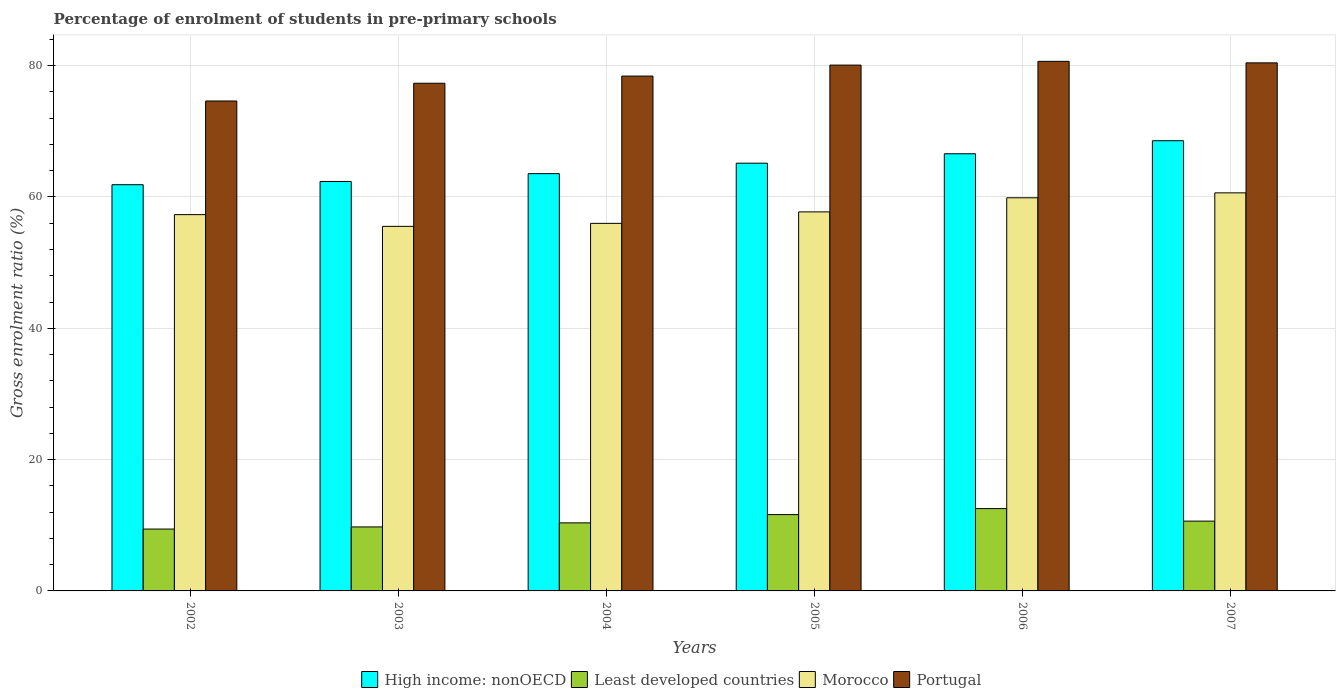How many different coloured bars are there?
Your response must be concise. 4. Are the number of bars on each tick of the X-axis equal?
Your answer should be very brief. Yes. How many bars are there on the 6th tick from the left?
Your answer should be very brief. 4. How many bars are there on the 3rd tick from the right?
Ensure brevity in your answer.  4. What is the percentage of students enrolled in pre-primary schools in Least developed countries in 2005?
Your answer should be compact. 11.62. Across all years, what is the maximum percentage of students enrolled in pre-primary schools in Portugal?
Ensure brevity in your answer.  80.65. Across all years, what is the minimum percentage of students enrolled in pre-primary schools in Least developed countries?
Ensure brevity in your answer.  9.42. In which year was the percentage of students enrolled in pre-primary schools in Morocco maximum?
Provide a succinct answer. 2007. What is the total percentage of students enrolled in pre-primary schools in Portugal in the graph?
Your answer should be very brief. 471.51. What is the difference between the percentage of students enrolled in pre-primary schools in High income: nonOECD in 2003 and that in 2006?
Your response must be concise. -4.22. What is the difference between the percentage of students enrolled in pre-primary schools in Portugal in 2006 and the percentage of students enrolled in pre-primary schools in Morocco in 2002?
Provide a succinct answer. 23.34. What is the average percentage of students enrolled in pre-primary schools in Morocco per year?
Give a very brief answer. 57.84. In the year 2003, what is the difference between the percentage of students enrolled in pre-primary schools in High income: nonOECD and percentage of students enrolled in pre-primary schools in Morocco?
Give a very brief answer. 6.84. What is the ratio of the percentage of students enrolled in pre-primary schools in Least developed countries in 2002 to that in 2003?
Your response must be concise. 0.97. Is the difference between the percentage of students enrolled in pre-primary schools in High income: nonOECD in 2002 and 2004 greater than the difference between the percentage of students enrolled in pre-primary schools in Morocco in 2002 and 2004?
Provide a short and direct response. No. What is the difference between the highest and the second highest percentage of students enrolled in pre-primary schools in High income: nonOECD?
Your answer should be compact. 1.98. What is the difference between the highest and the lowest percentage of students enrolled in pre-primary schools in High income: nonOECD?
Your answer should be compact. 6.7. Is the sum of the percentage of students enrolled in pre-primary schools in High income: nonOECD in 2003 and 2005 greater than the maximum percentage of students enrolled in pre-primary schools in Least developed countries across all years?
Your response must be concise. Yes. What does the 3rd bar from the left in 2006 represents?
Ensure brevity in your answer.  Morocco. What does the 2nd bar from the right in 2006 represents?
Provide a short and direct response. Morocco. Is it the case that in every year, the sum of the percentage of students enrolled in pre-primary schools in Portugal and percentage of students enrolled in pre-primary schools in Least developed countries is greater than the percentage of students enrolled in pre-primary schools in High income: nonOECD?
Make the answer very short. Yes. Are all the bars in the graph horizontal?
Offer a very short reply. No. What is the difference between two consecutive major ticks on the Y-axis?
Your answer should be compact. 20. Does the graph contain any zero values?
Provide a short and direct response. No. How are the legend labels stacked?
Your answer should be very brief. Horizontal. What is the title of the graph?
Your answer should be compact. Percentage of enrolment of students in pre-primary schools. What is the label or title of the X-axis?
Your answer should be compact. Years. What is the Gross enrolment ratio (%) in High income: nonOECD in 2002?
Your answer should be compact. 61.87. What is the Gross enrolment ratio (%) in Least developed countries in 2002?
Your response must be concise. 9.42. What is the Gross enrolment ratio (%) in Morocco in 2002?
Your answer should be very brief. 57.31. What is the Gross enrolment ratio (%) in Portugal in 2002?
Your response must be concise. 74.62. What is the Gross enrolment ratio (%) in High income: nonOECD in 2003?
Your answer should be compact. 62.36. What is the Gross enrolment ratio (%) in Least developed countries in 2003?
Provide a succinct answer. 9.75. What is the Gross enrolment ratio (%) in Morocco in 2003?
Offer a very short reply. 55.52. What is the Gross enrolment ratio (%) in Portugal in 2003?
Your answer should be compact. 77.32. What is the Gross enrolment ratio (%) in High income: nonOECD in 2004?
Give a very brief answer. 63.55. What is the Gross enrolment ratio (%) of Least developed countries in 2004?
Make the answer very short. 10.37. What is the Gross enrolment ratio (%) of Morocco in 2004?
Your answer should be compact. 55.98. What is the Gross enrolment ratio (%) of Portugal in 2004?
Your response must be concise. 78.41. What is the Gross enrolment ratio (%) in High income: nonOECD in 2005?
Offer a very short reply. 65.14. What is the Gross enrolment ratio (%) in Least developed countries in 2005?
Offer a very short reply. 11.62. What is the Gross enrolment ratio (%) of Morocco in 2005?
Your response must be concise. 57.73. What is the Gross enrolment ratio (%) in Portugal in 2005?
Make the answer very short. 80.08. What is the Gross enrolment ratio (%) in High income: nonOECD in 2006?
Your response must be concise. 66.58. What is the Gross enrolment ratio (%) of Least developed countries in 2006?
Your answer should be very brief. 12.54. What is the Gross enrolment ratio (%) of Morocco in 2006?
Keep it short and to the point. 59.88. What is the Gross enrolment ratio (%) in Portugal in 2006?
Keep it short and to the point. 80.65. What is the Gross enrolment ratio (%) in High income: nonOECD in 2007?
Give a very brief answer. 68.56. What is the Gross enrolment ratio (%) of Least developed countries in 2007?
Offer a very short reply. 10.63. What is the Gross enrolment ratio (%) in Morocco in 2007?
Keep it short and to the point. 60.63. What is the Gross enrolment ratio (%) in Portugal in 2007?
Offer a terse response. 80.43. Across all years, what is the maximum Gross enrolment ratio (%) of High income: nonOECD?
Make the answer very short. 68.56. Across all years, what is the maximum Gross enrolment ratio (%) in Least developed countries?
Your answer should be very brief. 12.54. Across all years, what is the maximum Gross enrolment ratio (%) of Morocco?
Your answer should be very brief. 60.63. Across all years, what is the maximum Gross enrolment ratio (%) of Portugal?
Keep it short and to the point. 80.65. Across all years, what is the minimum Gross enrolment ratio (%) in High income: nonOECD?
Provide a short and direct response. 61.87. Across all years, what is the minimum Gross enrolment ratio (%) of Least developed countries?
Your answer should be compact. 9.42. Across all years, what is the minimum Gross enrolment ratio (%) of Morocco?
Your answer should be very brief. 55.52. Across all years, what is the minimum Gross enrolment ratio (%) in Portugal?
Keep it short and to the point. 74.62. What is the total Gross enrolment ratio (%) of High income: nonOECD in the graph?
Your response must be concise. 388.07. What is the total Gross enrolment ratio (%) in Least developed countries in the graph?
Your response must be concise. 64.33. What is the total Gross enrolment ratio (%) of Morocco in the graph?
Provide a succinct answer. 347.04. What is the total Gross enrolment ratio (%) in Portugal in the graph?
Ensure brevity in your answer.  471.51. What is the difference between the Gross enrolment ratio (%) of High income: nonOECD in 2002 and that in 2003?
Ensure brevity in your answer.  -0.49. What is the difference between the Gross enrolment ratio (%) in Least developed countries in 2002 and that in 2003?
Provide a short and direct response. -0.32. What is the difference between the Gross enrolment ratio (%) in Morocco in 2002 and that in 2003?
Offer a terse response. 1.79. What is the difference between the Gross enrolment ratio (%) in Portugal in 2002 and that in 2003?
Offer a very short reply. -2.7. What is the difference between the Gross enrolment ratio (%) of High income: nonOECD in 2002 and that in 2004?
Provide a short and direct response. -1.68. What is the difference between the Gross enrolment ratio (%) in Least developed countries in 2002 and that in 2004?
Make the answer very short. -0.94. What is the difference between the Gross enrolment ratio (%) of Morocco in 2002 and that in 2004?
Offer a terse response. 1.33. What is the difference between the Gross enrolment ratio (%) in Portugal in 2002 and that in 2004?
Make the answer very short. -3.79. What is the difference between the Gross enrolment ratio (%) in High income: nonOECD in 2002 and that in 2005?
Your answer should be very brief. -3.28. What is the difference between the Gross enrolment ratio (%) in Least developed countries in 2002 and that in 2005?
Offer a terse response. -2.2. What is the difference between the Gross enrolment ratio (%) in Morocco in 2002 and that in 2005?
Ensure brevity in your answer.  -0.42. What is the difference between the Gross enrolment ratio (%) of Portugal in 2002 and that in 2005?
Give a very brief answer. -5.47. What is the difference between the Gross enrolment ratio (%) in High income: nonOECD in 2002 and that in 2006?
Ensure brevity in your answer.  -4.72. What is the difference between the Gross enrolment ratio (%) of Least developed countries in 2002 and that in 2006?
Ensure brevity in your answer.  -3.11. What is the difference between the Gross enrolment ratio (%) in Morocco in 2002 and that in 2006?
Keep it short and to the point. -2.57. What is the difference between the Gross enrolment ratio (%) in Portugal in 2002 and that in 2006?
Give a very brief answer. -6.04. What is the difference between the Gross enrolment ratio (%) of High income: nonOECD in 2002 and that in 2007?
Your response must be concise. -6.7. What is the difference between the Gross enrolment ratio (%) of Least developed countries in 2002 and that in 2007?
Your answer should be very brief. -1.21. What is the difference between the Gross enrolment ratio (%) in Morocco in 2002 and that in 2007?
Ensure brevity in your answer.  -3.32. What is the difference between the Gross enrolment ratio (%) in Portugal in 2002 and that in 2007?
Keep it short and to the point. -5.81. What is the difference between the Gross enrolment ratio (%) of High income: nonOECD in 2003 and that in 2004?
Your answer should be very brief. -1.19. What is the difference between the Gross enrolment ratio (%) of Least developed countries in 2003 and that in 2004?
Your response must be concise. -0.62. What is the difference between the Gross enrolment ratio (%) in Morocco in 2003 and that in 2004?
Your answer should be very brief. -0.46. What is the difference between the Gross enrolment ratio (%) of Portugal in 2003 and that in 2004?
Your response must be concise. -1.09. What is the difference between the Gross enrolment ratio (%) in High income: nonOECD in 2003 and that in 2005?
Your answer should be compact. -2.78. What is the difference between the Gross enrolment ratio (%) in Least developed countries in 2003 and that in 2005?
Keep it short and to the point. -1.88. What is the difference between the Gross enrolment ratio (%) of Morocco in 2003 and that in 2005?
Offer a terse response. -2.2. What is the difference between the Gross enrolment ratio (%) in Portugal in 2003 and that in 2005?
Your response must be concise. -2.76. What is the difference between the Gross enrolment ratio (%) in High income: nonOECD in 2003 and that in 2006?
Keep it short and to the point. -4.22. What is the difference between the Gross enrolment ratio (%) of Least developed countries in 2003 and that in 2006?
Offer a very short reply. -2.79. What is the difference between the Gross enrolment ratio (%) of Morocco in 2003 and that in 2006?
Make the answer very short. -4.35. What is the difference between the Gross enrolment ratio (%) of Portugal in 2003 and that in 2006?
Provide a short and direct response. -3.33. What is the difference between the Gross enrolment ratio (%) of High income: nonOECD in 2003 and that in 2007?
Ensure brevity in your answer.  -6.2. What is the difference between the Gross enrolment ratio (%) of Least developed countries in 2003 and that in 2007?
Your response must be concise. -0.88. What is the difference between the Gross enrolment ratio (%) in Morocco in 2003 and that in 2007?
Provide a succinct answer. -5.1. What is the difference between the Gross enrolment ratio (%) in Portugal in 2003 and that in 2007?
Ensure brevity in your answer.  -3.11. What is the difference between the Gross enrolment ratio (%) of High income: nonOECD in 2004 and that in 2005?
Ensure brevity in your answer.  -1.59. What is the difference between the Gross enrolment ratio (%) in Least developed countries in 2004 and that in 2005?
Provide a short and direct response. -1.26. What is the difference between the Gross enrolment ratio (%) of Morocco in 2004 and that in 2005?
Your response must be concise. -1.75. What is the difference between the Gross enrolment ratio (%) of Portugal in 2004 and that in 2005?
Offer a terse response. -1.67. What is the difference between the Gross enrolment ratio (%) in High income: nonOECD in 2004 and that in 2006?
Keep it short and to the point. -3.03. What is the difference between the Gross enrolment ratio (%) of Least developed countries in 2004 and that in 2006?
Your answer should be very brief. -2.17. What is the difference between the Gross enrolment ratio (%) in Morocco in 2004 and that in 2006?
Make the answer very short. -3.9. What is the difference between the Gross enrolment ratio (%) of Portugal in 2004 and that in 2006?
Provide a short and direct response. -2.24. What is the difference between the Gross enrolment ratio (%) of High income: nonOECD in 2004 and that in 2007?
Keep it short and to the point. -5.01. What is the difference between the Gross enrolment ratio (%) of Least developed countries in 2004 and that in 2007?
Keep it short and to the point. -0.27. What is the difference between the Gross enrolment ratio (%) of Morocco in 2004 and that in 2007?
Your answer should be compact. -4.65. What is the difference between the Gross enrolment ratio (%) in Portugal in 2004 and that in 2007?
Keep it short and to the point. -2.01. What is the difference between the Gross enrolment ratio (%) of High income: nonOECD in 2005 and that in 2006?
Your answer should be compact. -1.44. What is the difference between the Gross enrolment ratio (%) in Least developed countries in 2005 and that in 2006?
Provide a short and direct response. -0.91. What is the difference between the Gross enrolment ratio (%) in Morocco in 2005 and that in 2006?
Offer a terse response. -2.15. What is the difference between the Gross enrolment ratio (%) in Portugal in 2005 and that in 2006?
Provide a succinct answer. -0.57. What is the difference between the Gross enrolment ratio (%) in High income: nonOECD in 2005 and that in 2007?
Offer a terse response. -3.42. What is the difference between the Gross enrolment ratio (%) of Morocco in 2005 and that in 2007?
Provide a succinct answer. -2.9. What is the difference between the Gross enrolment ratio (%) in Portugal in 2005 and that in 2007?
Give a very brief answer. -0.34. What is the difference between the Gross enrolment ratio (%) of High income: nonOECD in 2006 and that in 2007?
Give a very brief answer. -1.98. What is the difference between the Gross enrolment ratio (%) in Least developed countries in 2006 and that in 2007?
Your answer should be compact. 1.91. What is the difference between the Gross enrolment ratio (%) of Morocco in 2006 and that in 2007?
Your answer should be very brief. -0.75. What is the difference between the Gross enrolment ratio (%) in Portugal in 2006 and that in 2007?
Make the answer very short. 0.23. What is the difference between the Gross enrolment ratio (%) in High income: nonOECD in 2002 and the Gross enrolment ratio (%) in Least developed countries in 2003?
Your response must be concise. 52.12. What is the difference between the Gross enrolment ratio (%) of High income: nonOECD in 2002 and the Gross enrolment ratio (%) of Morocco in 2003?
Your answer should be compact. 6.34. What is the difference between the Gross enrolment ratio (%) of High income: nonOECD in 2002 and the Gross enrolment ratio (%) of Portugal in 2003?
Your answer should be compact. -15.45. What is the difference between the Gross enrolment ratio (%) in Least developed countries in 2002 and the Gross enrolment ratio (%) in Morocco in 2003?
Offer a very short reply. -46.1. What is the difference between the Gross enrolment ratio (%) of Least developed countries in 2002 and the Gross enrolment ratio (%) of Portugal in 2003?
Make the answer very short. -67.9. What is the difference between the Gross enrolment ratio (%) in Morocco in 2002 and the Gross enrolment ratio (%) in Portugal in 2003?
Offer a very short reply. -20.01. What is the difference between the Gross enrolment ratio (%) of High income: nonOECD in 2002 and the Gross enrolment ratio (%) of Least developed countries in 2004?
Ensure brevity in your answer.  51.5. What is the difference between the Gross enrolment ratio (%) in High income: nonOECD in 2002 and the Gross enrolment ratio (%) in Morocco in 2004?
Make the answer very short. 5.89. What is the difference between the Gross enrolment ratio (%) in High income: nonOECD in 2002 and the Gross enrolment ratio (%) in Portugal in 2004?
Provide a succinct answer. -16.55. What is the difference between the Gross enrolment ratio (%) in Least developed countries in 2002 and the Gross enrolment ratio (%) in Morocco in 2004?
Your answer should be compact. -46.56. What is the difference between the Gross enrolment ratio (%) in Least developed countries in 2002 and the Gross enrolment ratio (%) in Portugal in 2004?
Your answer should be very brief. -68.99. What is the difference between the Gross enrolment ratio (%) of Morocco in 2002 and the Gross enrolment ratio (%) of Portugal in 2004?
Ensure brevity in your answer.  -21.1. What is the difference between the Gross enrolment ratio (%) in High income: nonOECD in 2002 and the Gross enrolment ratio (%) in Least developed countries in 2005?
Make the answer very short. 50.24. What is the difference between the Gross enrolment ratio (%) in High income: nonOECD in 2002 and the Gross enrolment ratio (%) in Morocco in 2005?
Offer a very short reply. 4.14. What is the difference between the Gross enrolment ratio (%) of High income: nonOECD in 2002 and the Gross enrolment ratio (%) of Portugal in 2005?
Provide a short and direct response. -18.22. What is the difference between the Gross enrolment ratio (%) of Least developed countries in 2002 and the Gross enrolment ratio (%) of Morocco in 2005?
Your answer should be compact. -48.3. What is the difference between the Gross enrolment ratio (%) in Least developed countries in 2002 and the Gross enrolment ratio (%) in Portugal in 2005?
Provide a succinct answer. -70.66. What is the difference between the Gross enrolment ratio (%) in Morocco in 2002 and the Gross enrolment ratio (%) in Portugal in 2005?
Provide a short and direct response. -22.77. What is the difference between the Gross enrolment ratio (%) in High income: nonOECD in 2002 and the Gross enrolment ratio (%) in Least developed countries in 2006?
Keep it short and to the point. 49.33. What is the difference between the Gross enrolment ratio (%) of High income: nonOECD in 2002 and the Gross enrolment ratio (%) of Morocco in 2006?
Offer a very short reply. 1.99. What is the difference between the Gross enrolment ratio (%) in High income: nonOECD in 2002 and the Gross enrolment ratio (%) in Portugal in 2006?
Offer a terse response. -18.79. What is the difference between the Gross enrolment ratio (%) of Least developed countries in 2002 and the Gross enrolment ratio (%) of Morocco in 2006?
Your answer should be very brief. -50.45. What is the difference between the Gross enrolment ratio (%) in Least developed countries in 2002 and the Gross enrolment ratio (%) in Portugal in 2006?
Offer a terse response. -71.23. What is the difference between the Gross enrolment ratio (%) in Morocco in 2002 and the Gross enrolment ratio (%) in Portugal in 2006?
Give a very brief answer. -23.34. What is the difference between the Gross enrolment ratio (%) of High income: nonOECD in 2002 and the Gross enrolment ratio (%) of Least developed countries in 2007?
Offer a terse response. 51.24. What is the difference between the Gross enrolment ratio (%) of High income: nonOECD in 2002 and the Gross enrolment ratio (%) of Morocco in 2007?
Provide a short and direct response. 1.24. What is the difference between the Gross enrolment ratio (%) in High income: nonOECD in 2002 and the Gross enrolment ratio (%) in Portugal in 2007?
Offer a terse response. -18.56. What is the difference between the Gross enrolment ratio (%) in Least developed countries in 2002 and the Gross enrolment ratio (%) in Morocco in 2007?
Make the answer very short. -51.2. What is the difference between the Gross enrolment ratio (%) in Least developed countries in 2002 and the Gross enrolment ratio (%) in Portugal in 2007?
Offer a terse response. -71. What is the difference between the Gross enrolment ratio (%) of Morocco in 2002 and the Gross enrolment ratio (%) of Portugal in 2007?
Ensure brevity in your answer.  -23.12. What is the difference between the Gross enrolment ratio (%) of High income: nonOECD in 2003 and the Gross enrolment ratio (%) of Least developed countries in 2004?
Make the answer very short. 51.99. What is the difference between the Gross enrolment ratio (%) in High income: nonOECD in 2003 and the Gross enrolment ratio (%) in Morocco in 2004?
Offer a very short reply. 6.38. What is the difference between the Gross enrolment ratio (%) in High income: nonOECD in 2003 and the Gross enrolment ratio (%) in Portugal in 2004?
Make the answer very short. -16.05. What is the difference between the Gross enrolment ratio (%) in Least developed countries in 2003 and the Gross enrolment ratio (%) in Morocco in 2004?
Your response must be concise. -46.23. What is the difference between the Gross enrolment ratio (%) in Least developed countries in 2003 and the Gross enrolment ratio (%) in Portugal in 2004?
Give a very brief answer. -68.66. What is the difference between the Gross enrolment ratio (%) of Morocco in 2003 and the Gross enrolment ratio (%) of Portugal in 2004?
Ensure brevity in your answer.  -22.89. What is the difference between the Gross enrolment ratio (%) of High income: nonOECD in 2003 and the Gross enrolment ratio (%) of Least developed countries in 2005?
Provide a succinct answer. 50.74. What is the difference between the Gross enrolment ratio (%) of High income: nonOECD in 2003 and the Gross enrolment ratio (%) of Morocco in 2005?
Make the answer very short. 4.63. What is the difference between the Gross enrolment ratio (%) of High income: nonOECD in 2003 and the Gross enrolment ratio (%) of Portugal in 2005?
Offer a very short reply. -17.72. What is the difference between the Gross enrolment ratio (%) in Least developed countries in 2003 and the Gross enrolment ratio (%) in Morocco in 2005?
Give a very brief answer. -47.98. What is the difference between the Gross enrolment ratio (%) in Least developed countries in 2003 and the Gross enrolment ratio (%) in Portugal in 2005?
Give a very brief answer. -70.34. What is the difference between the Gross enrolment ratio (%) in Morocco in 2003 and the Gross enrolment ratio (%) in Portugal in 2005?
Your answer should be compact. -24.56. What is the difference between the Gross enrolment ratio (%) of High income: nonOECD in 2003 and the Gross enrolment ratio (%) of Least developed countries in 2006?
Your answer should be compact. 49.82. What is the difference between the Gross enrolment ratio (%) in High income: nonOECD in 2003 and the Gross enrolment ratio (%) in Morocco in 2006?
Keep it short and to the point. 2.48. What is the difference between the Gross enrolment ratio (%) in High income: nonOECD in 2003 and the Gross enrolment ratio (%) in Portugal in 2006?
Ensure brevity in your answer.  -18.29. What is the difference between the Gross enrolment ratio (%) of Least developed countries in 2003 and the Gross enrolment ratio (%) of Morocco in 2006?
Make the answer very short. -50.13. What is the difference between the Gross enrolment ratio (%) of Least developed countries in 2003 and the Gross enrolment ratio (%) of Portugal in 2006?
Provide a short and direct response. -70.91. What is the difference between the Gross enrolment ratio (%) of Morocco in 2003 and the Gross enrolment ratio (%) of Portugal in 2006?
Your answer should be compact. -25.13. What is the difference between the Gross enrolment ratio (%) of High income: nonOECD in 2003 and the Gross enrolment ratio (%) of Least developed countries in 2007?
Offer a terse response. 51.73. What is the difference between the Gross enrolment ratio (%) of High income: nonOECD in 2003 and the Gross enrolment ratio (%) of Morocco in 2007?
Offer a very short reply. 1.73. What is the difference between the Gross enrolment ratio (%) of High income: nonOECD in 2003 and the Gross enrolment ratio (%) of Portugal in 2007?
Provide a short and direct response. -18.07. What is the difference between the Gross enrolment ratio (%) in Least developed countries in 2003 and the Gross enrolment ratio (%) in Morocco in 2007?
Your response must be concise. -50.88. What is the difference between the Gross enrolment ratio (%) in Least developed countries in 2003 and the Gross enrolment ratio (%) in Portugal in 2007?
Your answer should be very brief. -70.68. What is the difference between the Gross enrolment ratio (%) in Morocco in 2003 and the Gross enrolment ratio (%) in Portugal in 2007?
Your response must be concise. -24.9. What is the difference between the Gross enrolment ratio (%) of High income: nonOECD in 2004 and the Gross enrolment ratio (%) of Least developed countries in 2005?
Ensure brevity in your answer.  51.93. What is the difference between the Gross enrolment ratio (%) in High income: nonOECD in 2004 and the Gross enrolment ratio (%) in Morocco in 2005?
Provide a short and direct response. 5.82. What is the difference between the Gross enrolment ratio (%) in High income: nonOECD in 2004 and the Gross enrolment ratio (%) in Portugal in 2005?
Offer a very short reply. -16.53. What is the difference between the Gross enrolment ratio (%) of Least developed countries in 2004 and the Gross enrolment ratio (%) of Morocco in 2005?
Make the answer very short. -47.36. What is the difference between the Gross enrolment ratio (%) in Least developed countries in 2004 and the Gross enrolment ratio (%) in Portugal in 2005?
Provide a succinct answer. -69.72. What is the difference between the Gross enrolment ratio (%) of Morocco in 2004 and the Gross enrolment ratio (%) of Portugal in 2005?
Give a very brief answer. -24.1. What is the difference between the Gross enrolment ratio (%) in High income: nonOECD in 2004 and the Gross enrolment ratio (%) in Least developed countries in 2006?
Keep it short and to the point. 51.01. What is the difference between the Gross enrolment ratio (%) in High income: nonOECD in 2004 and the Gross enrolment ratio (%) in Morocco in 2006?
Keep it short and to the point. 3.67. What is the difference between the Gross enrolment ratio (%) in High income: nonOECD in 2004 and the Gross enrolment ratio (%) in Portugal in 2006?
Give a very brief answer. -17.1. What is the difference between the Gross enrolment ratio (%) of Least developed countries in 2004 and the Gross enrolment ratio (%) of Morocco in 2006?
Give a very brief answer. -49.51. What is the difference between the Gross enrolment ratio (%) in Least developed countries in 2004 and the Gross enrolment ratio (%) in Portugal in 2006?
Make the answer very short. -70.29. What is the difference between the Gross enrolment ratio (%) in Morocco in 2004 and the Gross enrolment ratio (%) in Portugal in 2006?
Keep it short and to the point. -24.67. What is the difference between the Gross enrolment ratio (%) of High income: nonOECD in 2004 and the Gross enrolment ratio (%) of Least developed countries in 2007?
Offer a very short reply. 52.92. What is the difference between the Gross enrolment ratio (%) in High income: nonOECD in 2004 and the Gross enrolment ratio (%) in Morocco in 2007?
Your response must be concise. 2.92. What is the difference between the Gross enrolment ratio (%) of High income: nonOECD in 2004 and the Gross enrolment ratio (%) of Portugal in 2007?
Provide a short and direct response. -16.88. What is the difference between the Gross enrolment ratio (%) in Least developed countries in 2004 and the Gross enrolment ratio (%) in Morocco in 2007?
Your response must be concise. -50.26. What is the difference between the Gross enrolment ratio (%) of Least developed countries in 2004 and the Gross enrolment ratio (%) of Portugal in 2007?
Offer a very short reply. -70.06. What is the difference between the Gross enrolment ratio (%) of Morocco in 2004 and the Gross enrolment ratio (%) of Portugal in 2007?
Keep it short and to the point. -24.45. What is the difference between the Gross enrolment ratio (%) of High income: nonOECD in 2005 and the Gross enrolment ratio (%) of Least developed countries in 2006?
Offer a very short reply. 52.61. What is the difference between the Gross enrolment ratio (%) of High income: nonOECD in 2005 and the Gross enrolment ratio (%) of Morocco in 2006?
Your answer should be very brief. 5.27. What is the difference between the Gross enrolment ratio (%) in High income: nonOECD in 2005 and the Gross enrolment ratio (%) in Portugal in 2006?
Give a very brief answer. -15.51. What is the difference between the Gross enrolment ratio (%) of Least developed countries in 2005 and the Gross enrolment ratio (%) of Morocco in 2006?
Ensure brevity in your answer.  -48.25. What is the difference between the Gross enrolment ratio (%) of Least developed countries in 2005 and the Gross enrolment ratio (%) of Portugal in 2006?
Make the answer very short. -69.03. What is the difference between the Gross enrolment ratio (%) in Morocco in 2005 and the Gross enrolment ratio (%) in Portugal in 2006?
Offer a very short reply. -22.93. What is the difference between the Gross enrolment ratio (%) in High income: nonOECD in 2005 and the Gross enrolment ratio (%) in Least developed countries in 2007?
Offer a terse response. 54.51. What is the difference between the Gross enrolment ratio (%) of High income: nonOECD in 2005 and the Gross enrolment ratio (%) of Morocco in 2007?
Provide a succinct answer. 4.52. What is the difference between the Gross enrolment ratio (%) of High income: nonOECD in 2005 and the Gross enrolment ratio (%) of Portugal in 2007?
Provide a short and direct response. -15.28. What is the difference between the Gross enrolment ratio (%) in Least developed countries in 2005 and the Gross enrolment ratio (%) in Morocco in 2007?
Provide a short and direct response. -49. What is the difference between the Gross enrolment ratio (%) of Least developed countries in 2005 and the Gross enrolment ratio (%) of Portugal in 2007?
Make the answer very short. -68.8. What is the difference between the Gross enrolment ratio (%) of Morocco in 2005 and the Gross enrolment ratio (%) of Portugal in 2007?
Offer a terse response. -22.7. What is the difference between the Gross enrolment ratio (%) of High income: nonOECD in 2006 and the Gross enrolment ratio (%) of Least developed countries in 2007?
Ensure brevity in your answer.  55.95. What is the difference between the Gross enrolment ratio (%) in High income: nonOECD in 2006 and the Gross enrolment ratio (%) in Morocco in 2007?
Give a very brief answer. 5.95. What is the difference between the Gross enrolment ratio (%) in High income: nonOECD in 2006 and the Gross enrolment ratio (%) in Portugal in 2007?
Your answer should be compact. -13.84. What is the difference between the Gross enrolment ratio (%) of Least developed countries in 2006 and the Gross enrolment ratio (%) of Morocco in 2007?
Your answer should be compact. -48.09. What is the difference between the Gross enrolment ratio (%) in Least developed countries in 2006 and the Gross enrolment ratio (%) in Portugal in 2007?
Keep it short and to the point. -67.89. What is the difference between the Gross enrolment ratio (%) of Morocco in 2006 and the Gross enrolment ratio (%) of Portugal in 2007?
Your answer should be compact. -20.55. What is the average Gross enrolment ratio (%) of High income: nonOECD per year?
Your response must be concise. 64.68. What is the average Gross enrolment ratio (%) of Least developed countries per year?
Keep it short and to the point. 10.72. What is the average Gross enrolment ratio (%) of Morocco per year?
Offer a terse response. 57.84. What is the average Gross enrolment ratio (%) of Portugal per year?
Make the answer very short. 78.58. In the year 2002, what is the difference between the Gross enrolment ratio (%) in High income: nonOECD and Gross enrolment ratio (%) in Least developed countries?
Offer a terse response. 52.44. In the year 2002, what is the difference between the Gross enrolment ratio (%) in High income: nonOECD and Gross enrolment ratio (%) in Morocco?
Keep it short and to the point. 4.56. In the year 2002, what is the difference between the Gross enrolment ratio (%) of High income: nonOECD and Gross enrolment ratio (%) of Portugal?
Your answer should be very brief. -12.75. In the year 2002, what is the difference between the Gross enrolment ratio (%) in Least developed countries and Gross enrolment ratio (%) in Morocco?
Ensure brevity in your answer.  -47.89. In the year 2002, what is the difference between the Gross enrolment ratio (%) in Least developed countries and Gross enrolment ratio (%) in Portugal?
Give a very brief answer. -65.19. In the year 2002, what is the difference between the Gross enrolment ratio (%) in Morocco and Gross enrolment ratio (%) in Portugal?
Keep it short and to the point. -17.31. In the year 2003, what is the difference between the Gross enrolment ratio (%) in High income: nonOECD and Gross enrolment ratio (%) in Least developed countries?
Your answer should be compact. 52.61. In the year 2003, what is the difference between the Gross enrolment ratio (%) of High income: nonOECD and Gross enrolment ratio (%) of Morocco?
Your answer should be compact. 6.84. In the year 2003, what is the difference between the Gross enrolment ratio (%) in High income: nonOECD and Gross enrolment ratio (%) in Portugal?
Your response must be concise. -14.96. In the year 2003, what is the difference between the Gross enrolment ratio (%) of Least developed countries and Gross enrolment ratio (%) of Morocco?
Ensure brevity in your answer.  -45.78. In the year 2003, what is the difference between the Gross enrolment ratio (%) in Least developed countries and Gross enrolment ratio (%) in Portugal?
Provide a succinct answer. -67.57. In the year 2003, what is the difference between the Gross enrolment ratio (%) of Morocco and Gross enrolment ratio (%) of Portugal?
Offer a very short reply. -21.8. In the year 2004, what is the difference between the Gross enrolment ratio (%) of High income: nonOECD and Gross enrolment ratio (%) of Least developed countries?
Provide a short and direct response. 53.18. In the year 2004, what is the difference between the Gross enrolment ratio (%) of High income: nonOECD and Gross enrolment ratio (%) of Morocco?
Ensure brevity in your answer.  7.57. In the year 2004, what is the difference between the Gross enrolment ratio (%) of High income: nonOECD and Gross enrolment ratio (%) of Portugal?
Your answer should be compact. -14.86. In the year 2004, what is the difference between the Gross enrolment ratio (%) in Least developed countries and Gross enrolment ratio (%) in Morocco?
Ensure brevity in your answer.  -45.61. In the year 2004, what is the difference between the Gross enrolment ratio (%) of Least developed countries and Gross enrolment ratio (%) of Portugal?
Make the answer very short. -68.05. In the year 2004, what is the difference between the Gross enrolment ratio (%) of Morocco and Gross enrolment ratio (%) of Portugal?
Provide a short and direct response. -22.43. In the year 2005, what is the difference between the Gross enrolment ratio (%) in High income: nonOECD and Gross enrolment ratio (%) in Least developed countries?
Your answer should be compact. 53.52. In the year 2005, what is the difference between the Gross enrolment ratio (%) of High income: nonOECD and Gross enrolment ratio (%) of Morocco?
Give a very brief answer. 7.42. In the year 2005, what is the difference between the Gross enrolment ratio (%) in High income: nonOECD and Gross enrolment ratio (%) in Portugal?
Keep it short and to the point. -14.94. In the year 2005, what is the difference between the Gross enrolment ratio (%) in Least developed countries and Gross enrolment ratio (%) in Morocco?
Make the answer very short. -46.1. In the year 2005, what is the difference between the Gross enrolment ratio (%) in Least developed countries and Gross enrolment ratio (%) in Portugal?
Provide a short and direct response. -68.46. In the year 2005, what is the difference between the Gross enrolment ratio (%) of Morocco and Gross enrolment ratio (%) of Portugal?
Your answer should be very brief. -22.36. In the year 2006, what is the difference between the Gross enrolment ratio (%) in High income: nonOECD and Gross enrolment ratio (%) in Least developed countries?
Keep it short and to the point. 54.04. In the year 2006, what is the difference between the Gross enrolment ratio (%) of High income: nonOECD and Gross enrolment ratio (%) of Morocco?
Offer a terse response. 6.71. In the year 2006, what is the difference between the Gross enrolment ratio (%) of High income: nonOECD and Gross enrolment ratio (%) of Portugal?
Your answer should be compact. -14.07. In the year 2006, what is the difference between the Gross enrolment ratio (%) of Least developed countries and Gross enrolment ratio (%) of Morocco?
Your answer should be very brief. -47.34. In the year 2006, what is the difference between the Gross enrolment ratio (%) of Least developed countries and Gross enrolment ratio (%) of Portugal?
Provide a short and direct response. -68.12. In the year 2006, what is the difference between the Gross enrolment ratio (%) of Morocco and Gross enrolment ratio (%) of Portugal?
Offer a very short reply. -20.78. In the year 2007, what is the difference between the Gross enrolment ratio (%) of High income: nonOECD and Gross enrolment ratio (%) of Least developed countries?
Your answer should be compact. 57.93. In the year 2007, what is the difference between the Gross enrolment ratio (%) in High income: nonOECD and Gross enrolment ratio (%) in Morocco?
Give a very brief answer. 7.94. In the year 2007, what is the difference between the Gross enrolment ratio (%) of High income: nonOECD and Gross enrolment ratio (%) of Portugal?
Offer a terse response. -11.86. In the year 2007, what is the difference between the Gross enrolment ratio (%) in Least developed countries and Gross enrolment ratio (%) in Morocco?
Ensure brevity in your answer.  -50. In the year 2007, what is the difference between the Gross enrolment ratio (%) of Least developed countries and Gross enrolment ratio (%) of Portugal?
Keep it short and to the point. -69.79. In the year 2007, what is the difference between the Gross enrolment ratio (%) of Morocco and Gross enrolment ratio (%) of Portugal?
Offer a terse response. -19.8. What is the ratio of the Gross enrolment ratio (%) in High income: nonOECD in 2002 to that in 2003?
Make the answer very short. 0.99. What is the ratio of the Gross enrolment ratio (%) of Least developed countries in 2002 to that in 2003?
Keep it short and to the point. 0.97. What is the ratio of the Gross enrolment ratio (%) of Morocco in 2002 to that in 2003?
Give a very brief answer. 1.03. What is the ratio of the Gross enrolment ratio (%) in High income: nonOECD in 2002 to that in 2004?
Provide a succinct answer. 0.97. What is the ratio of the Gross enrolment ratio (%) of Morocco in 2002 to that in 2004?
Make the answer very short. 1.02. What is the ratio of the Gross enrolment ratio (%) of Portugal in 2002 to that in 2004?
Your response must be concise. 0.95. What is the ratio of the Gross enrolment ratio (%) in High income: nonOECD in 2002 to that in 2005?
Keep it short and to the point. 0.95. What is the ratio of the Gross enrolment ratio (%) of Least developed countries in 2002 to that in 2005?
Provide a short and direct response. 0.81. What is the ratio of the Gross enrolment ratio (%) of Morocco in 2002 to that in 2005?
Offer a terse response. 0.99. What is the ratio of the Gross enrolment ratio (%) in Portugal in 2002 to that in 2005?
Provide a short and direct response. 0.93. What is the ratio of the Gross enrolment ratio (%) in High income: nonOECD in 2002 to that in 2006?
Your answer should be very brief. 0.93. What is the ratio of the Gross enrolment ratio (%) of Least developed countries in 2002 to that in 2006?
Offer a terse response. 0.75. What is the ratio of the Gross enrolment ratio (%) of Morocco in 2002 to that in 2006?
Keep it short and to the point. 0.96. What is the ratio of the Gross enrolment ratio (%) of Portugal in 2002 to that in 2006?
Offer a very short reply. 0.93. What is the ratio of the Gross enrolment ratio (%) of High income: nonOECD in 2002 to that in 2007?
Offer a terse response. 0.9. What is the ratio of the Gross enrolment ratio (%) of Least developed countries in 2002 to that in 2007?
Ensure brevity in your answer.  0.89. What is the ratio of the Gross enrolment ratio (%) of Morocco in 2002 to that in 2007?
Your answer should be compact. 0.95. What is the ratio of the Gross enrolment ratio (%) in Portugal in 2002 to that in 2007?
Provide a succinct answer. 0.93. What is the ratio of the Gross enrolment ratio (%) in High income: nonOECD in 2003 to that in 2004?
Give a very brief answer. 0.98. What is the ratio of the Gross enrolment ratio (%) in Least developed countries in 2003 to that in 2004?
Provide a succinct answer. 0.94. What is the ratio of the Gross enrolment ratio (%) in Morocco in 2003 to that in 2004?
Keep it short and to the point. 0.99. What is the ratio of the Gross enrolment ratio (%) in Portugal in 2003 to that in 2004?
Your response must be concise. 0.99. What is the ratio of the Gross enrolment ratio (%) of High income: nonOECD in 2003 to that in 2005?
Keep it short and to the point. 0.96. What is the ratio of the Gross enrolment ratio (%) in Least developed countries in 2003 to that in 2005?
Offer a very short reply. 0.84. What is the ratio of the Gross enrolment ratio (%) in Morocco in 2003 to that in 2005?
Provide a short and direct response. 0.96. What is the ratio of the Gross enrolment ratio (%) of Portugal in 2003 to that in 2005?
Keep it short and to the point. 0.97. What is the ratio of the Gross enrolment ratio (%) of High income: nonOECD in 2003 to that in 2006?
Make the answer very short. 0.94. What is the ratio of the Gross enrolment ratio (%) in Least developed countries in 2003 to that in 2006?
Offer a terse response. 0.78. What is the ratio of the Gross enrolment ratio (%) in Morocco in 2003 to that in 2006?
Your answer should be compact. 0.93. What is the ratio of the Gross enrolment ratio (%) in Portugal in 2003 to that in 2006?
Offer a terse response. 0.96. What is the ratio of the Gross enrolment ratio (%) in High income: nonOECD in 2003 to that in 2007?
Keep it short and to the point. 0.91. What is the ratio of the Gross enrolment ratio (%) of Least developed countries in 2003 to that in 2007?
Offer a very short reply. 0.92. What is the ratio of the Gross enrolment ratio (%) in Morocco in 2003 to that in 2007?
Provide a succinct answer. 0.92. What is the ratio of the Gross enrolment ratio (%) in Portugal in 2003 to that in 2007?
Your answer should be very brief. 0.96. What is the ratio of the Gross enrolment ratio (%) of High income: nonOECD in 2004 to that in 2005?
Your answer should be very brief. 0.98. What is the ratio of the Gross enrolment ratio (%) of Least developed countries in 2004 to that in 2005?
Ensure brevity in your answer.  0.89. What is the ratio of the Gross enrolment ratio (%) of Morocco in 2004 to that in 2005?
Your answer should be compact. 0.97. What is the ratio of the Gross enrolment ratio (%) of Portugal in 2004 to that in 2005?
Make the answer very short. 0.98. What is the ratio of the Gross enrolment ratio (%) in High income: nonOECD in 2004 to that in 2006?
Your response must be concise. 0.95. What is the ratio of the Gross enrolment ratio (%) of Least developed countries in 2004 to that in 2006?
Ensure brevity in your answer.  0.83. What is the ratio of the Gross enrolment ratio (%) of Morocco in 2004 to that in 2006?
Ensure brevity in your answer.  0.93. What is the ratio of the Gross enrolment ratio (%) of Portugal in 2004 to that in 2006?
Provide a succinct answer. 0.97. What is the ratio of the Gross enrolment ratio (%) of High income: nonOECD in 2004 to that in 2007?
Your answer should be compact. 0.93. What is the ratio of the Gross enrolment ratio (%) in Morocco in 2004 to that in 2007?
Ensure brevity in your answer.  0.92. What is the ratio of the Gross enrolment ratio (%) of Portugal in 2004 to that in 2007?
Your answer should be very brief. 0.97. What is the ratio of the Gross enrolment ratio (%) in High income: nonOECD in 2005 to that in 2006?
Your answer should be very brief. 0.98. What is the ratio of the Gross enrolment ratio (%) in Least developed countries in 2005 to that in 2006?
Your response must be concise. 0.93. What is the ratio of the Gross enrolment ratio (%) of Morocco in 2005 to that in 2006?
Make the answer very short. 0.96. What is the ratio of the Gross enrolment ratio (%) in High income: nonOECD in 2005 to that in 2007?
Offer a very short reply. 0.95. What is the ratio of the Gross enrolment ratio (%) of Least developed countries in 2005 to that in 2007?
Provide a short and direct response. 1.09. What is the ratio of the Gross enrolment ratio (%) in Morocco in 2005 to that in 2007?
Make the answer very short. 0.95. What is the ratio of the Gross enrolment ratio (%) of High income: nonOECD in 2006 to that in 2007?
Your answer should be very brief. 0.97. What is the ratio of the Gross enrolment ratio (%) of Least developed countries in 2006 to that in 2007?
Offer a very short reply. 1.18. What is the ratio of the Gross enrolment ratio (%) of Morocco in 2006 to that in 2007?
Your response must be concise. 0.99. What is the ratio of the Gross enrolment ratio (%) of Portugal in 2006 to that in 2007?
Give a very brief answer. 1. What is the difference between the highest and the second highest Gross enrolment ratio (%) of High income: nonOECD?
Offer a terse response. 1.98. What is the difference between the highest and the second highest Gross enrolment ratio (%) in Least developed countries?
Keep it short and to the point. 0.91. What is the difference between the highest and the second highest Gross enrolment ratio (%) of Morocco?
Provide a short and direct response. 0.75. What is the difference between the highest and the second highest Gross enrolment ratio (%) of Portugal?
Make the answer very short. 0.23. What is the difference between the highest and the lowest Gross enrolment ratio (%) in High income: nonOECD?
Offer a terse response. 6.7. What is the difference between the highest and the lowest Gross enrolment ratio (%) of Least developed countries?
Offer a very short reply. 3.11. What is the difference between the highest and the lowest Gross enrolment ratio (%) in Morocco?
Keep it short and to the point. 5.1. What is the difference between the highest and the lowest Gross enrolment ratio (%) of Portugal?
Make the answer very short. 6.04. 